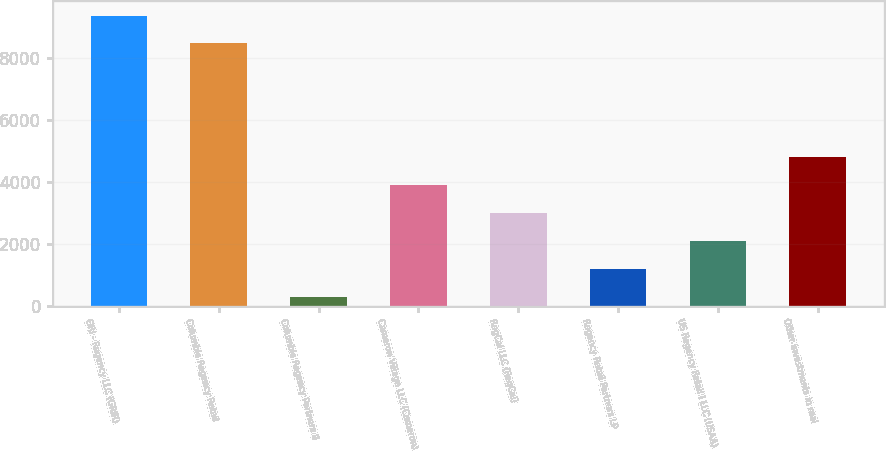<chart> <loc_0><loc_0><loc_500><loc_500><bar_chart><fcel>GRI - Regency LLC (GRIR)<fcel>Columbia Regency Retail<fcel>Columbia Regency Partners II<fcel>Cameron Village LLC (Cameron)<fcel>RegCal LLC (RegCal)<fcel>Regency Retail Partners LP<fcel>US Regency Retail I LLC (USAA)<fcel>Other investments in real<nl><fcel>9382.1<fcel>8480<fcel>290<fcel>3898.4<fcel>2996.3<fcel>1192.1<fcel>2094.2<fcel>4800.5<nl></chart> 